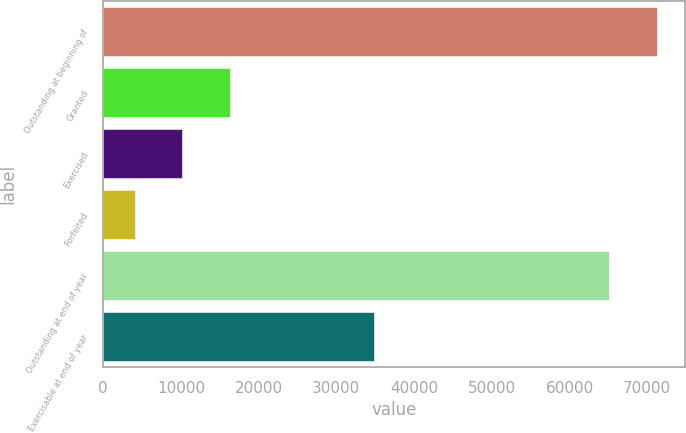Convert chart. <chart><loc_0><loc_0><loc_500><loc_500><bar_chart><fcel>Outstanding at beginning of<fcel>Granted<fcel>Exercised<fcel>Forfeited<fcel>Outstanding at end of year<fcel>Exercisable at end of year<nl><fcel>71255.6<fcel>16298.2<fcel>10177.6<fcel>4057<fcel>65135<fcel>34844<nl></chart> 